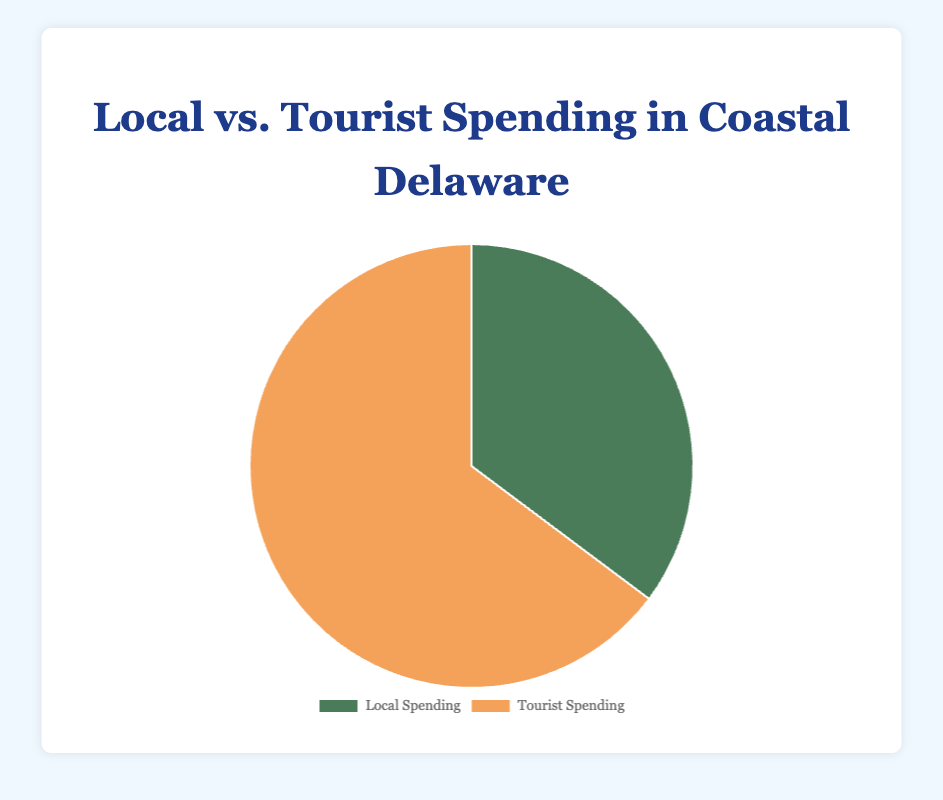What is the total spending amount for locals and tourists combined? To find the total, sum the spending for locals and tourists. Local spending is $8,700,000 and tourist spending is $16,000,000, so the total is $8,700,000 + $16,000,000 = $24,700,000.
Answer: $24,700,000 Which group spends more overall, locals or tourists? Compare the total spending amounts. Tourist spending is $16,000,000, while local spending is $8,700,000. Tourists spend more.
Answer: Tourists How much more do tourists spend than locals? Subtract the local spending from the tourist spending. $16,000,000 - $8,700,000 = $7,300,000.
Answer: $7,300,000 If the local spending on Dining increased by 50%, how would that impact the total local spending? First, calculate the 50% increase for Dining: 50% of $2,000,000 is $1,000,000. Add this to the original spending to get the new Dining spending ($2,000,000 + $1,000,000 = $3,000,000). The new total local spending is the old total plus the increase: $8,700,000 + $1,000,000 = $9,700,000.
Answer: $9,700,000 Calculate the percentage of total spending attributed to locals. The local spending is $8,700,000 and the total spending is $24,700,000. The percentage is ($8,700,000 / $24,700,000) * 100%.
Answer: 35.22% Identify the segment that contributes the most to tourist spending. Looking at the segments for tourist spending, Accommodation has the highest value with $5,000,000.
Answer: Accommodation If we combine the "Dining" expenditure for both locals and tourists, what is the total amount spent? Add local Dining ($2,000,000) and tourist Dining ($4,000,000) together. $2,000,000 + $4,000,000 = $6,000,000.
Answer: $6,000,000 Which segment has the lowest spending for locals? Look at the local spending segments and compare them. Healthcare has the lowest amount of $1,000,000.
Answer: Healthcare 